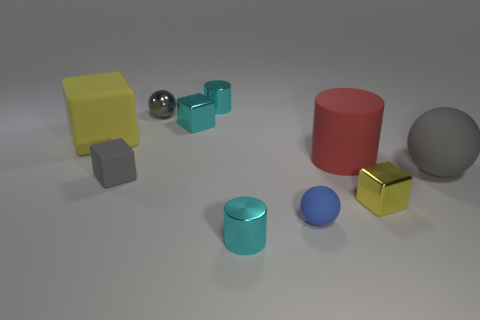Subtract 1 cubes. How many cubes are left? 3 Subtract all small cyan cubes. How many cubes are left? 3 Subtract all green blocks. Subtract all green cylinders. How many blocks are left? 4 Subtract all cylinders. How many objects are left? 7 Add 3 rubber cylinders. How many rubber cylinders are left? 4 Add 8 tiny yellow cubes. How many tiny yellow cubes exist? 9 Subtract 0 red cubes. How many objects are left? 10 Subtract all cyan metal cylinders. Subtract all small matte objects. How many objects are left? 6 